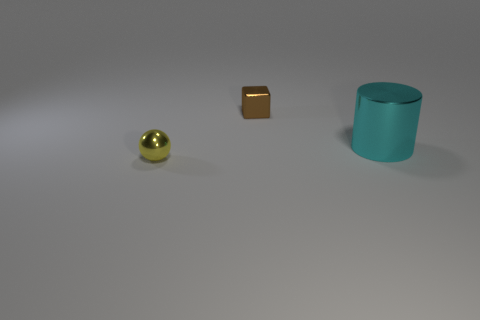There is a tiny thing that is to the left of the brown metal thing; is its shape the same as the large cyan thing?
Provide a succinct answer. No. Is there any other thing of the same color as the shiny cylinder?
Offer a terse response. No. There is another yellow object that is the same material as the large thing; what is its size?
Ensure brevity in your answer.  Small. What is the material of the thing right of the tiny thing that is behind the metallic object that is right of the brown shiny cube?
Keep it short and to the point. Metal. Are there fewer big brown rubber things than large metallic cylinders?
Give a very brief answer. Yes. Is the material of the big cyan thing the same as the yellow ball?
Offer a terse response. Yes. There is a small metal object that is on the right side of the tiny yellow object; is its color the same as the large thing?
Offer a terse response. No. There is a large shiny object that is on the right side of the metal block; what number of things are behind it?
Provide a short and direct response. 1. What is the color of the other metallic thing that is the same size as the brown thing?
Provide a succinct answer. Yellow. There is a thing that is behind the big cyan shiny cylinder; what is it made of?
Offer a very short reply. Metal. 